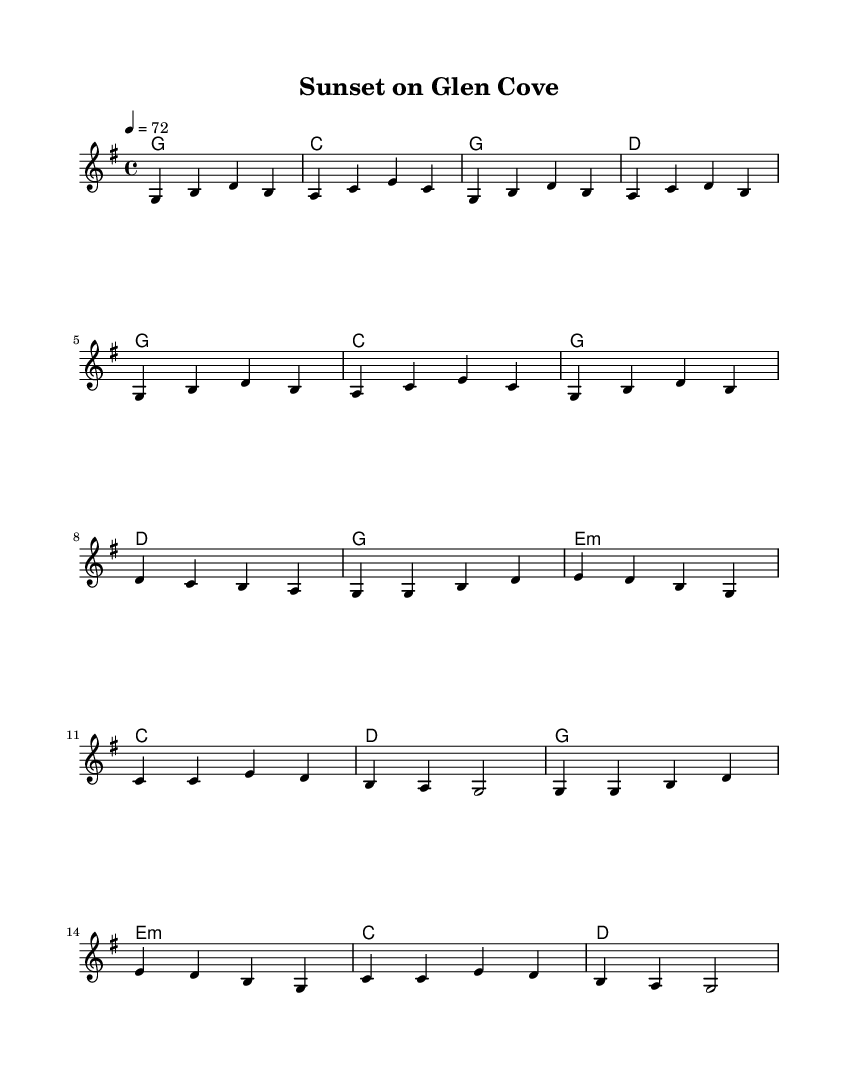What is the key signature of this music? The key signature is G major, which has one sharp (F#). This can be confirmed by looking at the beginning of the music sheet, where the key signature is indicated.
Answer: G major What is the time signature of this music? The time signature is 4/4, which can be identified at the beginning of the staff. It indicates there are four beats in each measure.
Answer: 4/4 What is the tempo marking in this music? The tempo marking is 72 beats per minute, as noted in the tempo indication at the start of the score. This specifies how fast the music should be played.
Answer: 72 How many measures are in the verse? The verse consists of eight measures, as can be counted from the beginning of the verse section in the sheet music to its end.
Answer: 8 In which section do the lyrics talk about "Sunset on Glen Cove"? The lyrics mentioning "Sunset on Glen Cove" appear in the chorus section, which follows the verse. This is where the recurring thematic material of the song is expressed.
Answer: Chorus What chords are used in the chorus section? The chords in the chorus are G, E minor, C, and D. These can be found beneath the melody in the chord names section, matching the notes played during the chorus lyrics.
Answer: G, E minor, C, D What is the mood of the lyrics based on the content? The mood of the lyrics conveys a feeling of tranquility and contentment, reflecting a sense of peace after a long day, as indicated by the imagery and emotions expressed in the words.
Answer: Tranquility 